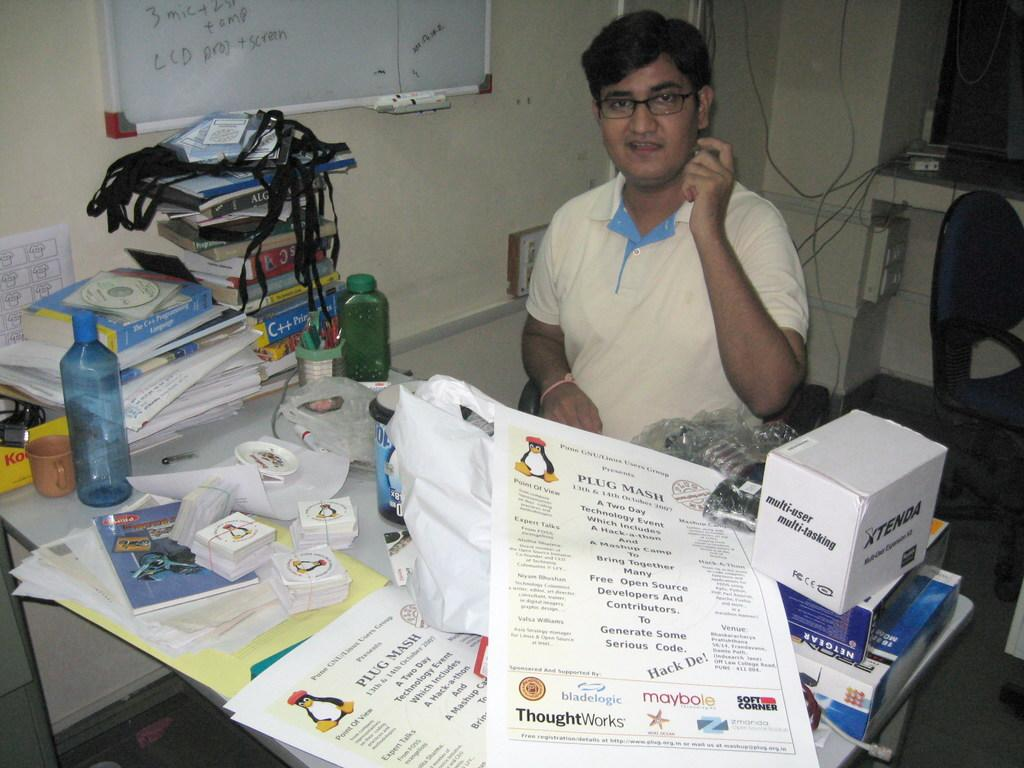What is the man in the image doing? The man is sitting on a chair in the image. What can be seen on the table in the image? There are bottles, books, papers, a box, and other objects on the table. Can you describe the objects on the table in more detail? The bottles, books, papers, and box are clearly visible, but the other objects are not specified. What type of stone is the man holding in the image? There is no stone present in the image; the man is sitting on a chair and there are objects on the table. What color is the flesh of the moon in the image? There is no moon present in the image, and therefore no flesh to describe. 